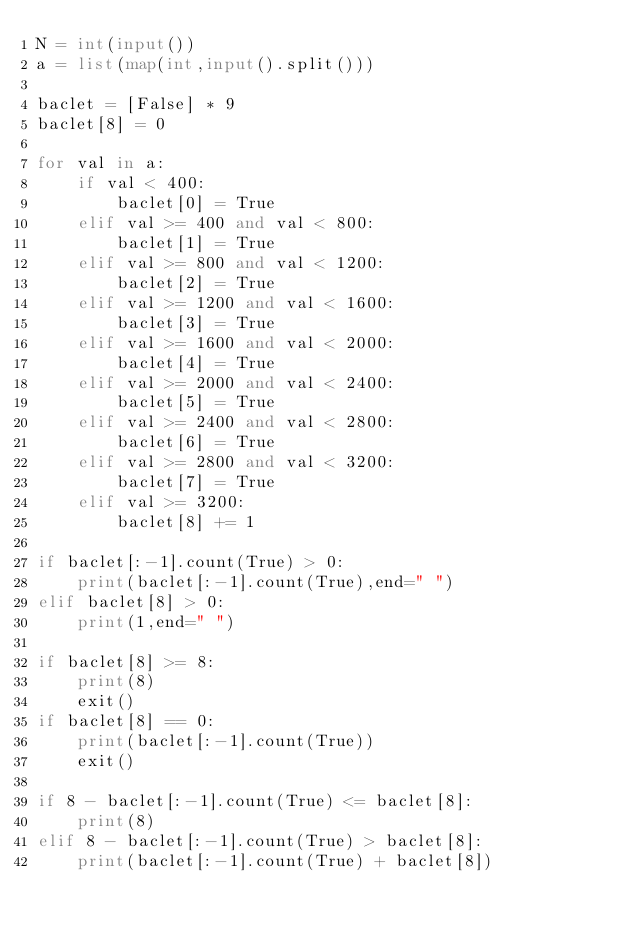<code> <loc_0><loc_0><loc_500><loc_500><_Python_>N = int(input())
a = list(map(int,input().split()))

baclet = [False] * 9
baclet[8] = 0

for val in a:
    if val < 400:
        baclet[0] = True
    elif val >= 400 and val < 800: 
        baclet[1] = True
    elif val >= 800 and val < 1200: 
        baclet[2] = True
    elif val >= 1200 and val < 1600: 
        baclet[3] = True
    elif val >= 1600 and val < 2000: 
        baclet[4] = True
    elif val >= 2000 and val < 2400: 
        baclet[5] = True
    elif val >= 2400 and val < 2800: 
        baclet[6] = True
    elif val >= 2800 and val < 3200: 
        baclet[7] = True
    elif val >= 3200: 
        baclet[8] += 1

if baclet[:-1].count(True) > 0:
    print(baclet[:-1].count(True),end=" ")
elif baclet[8] > 0:
    print(1,end=" ")

if baclet[8] >= 8:
    print(8)
    exit()
if baclet[8] == 0:
    print(baclet[:-1].count(True))
    exit()

if 8 - baclet[:-1].count(True) <= baclet[8]:
    print(8)
elif 8 - baclet[:-1].count(True) > baclet[8]:
    print(baclet[:-1].count(True) + baclet[8])
</code> 